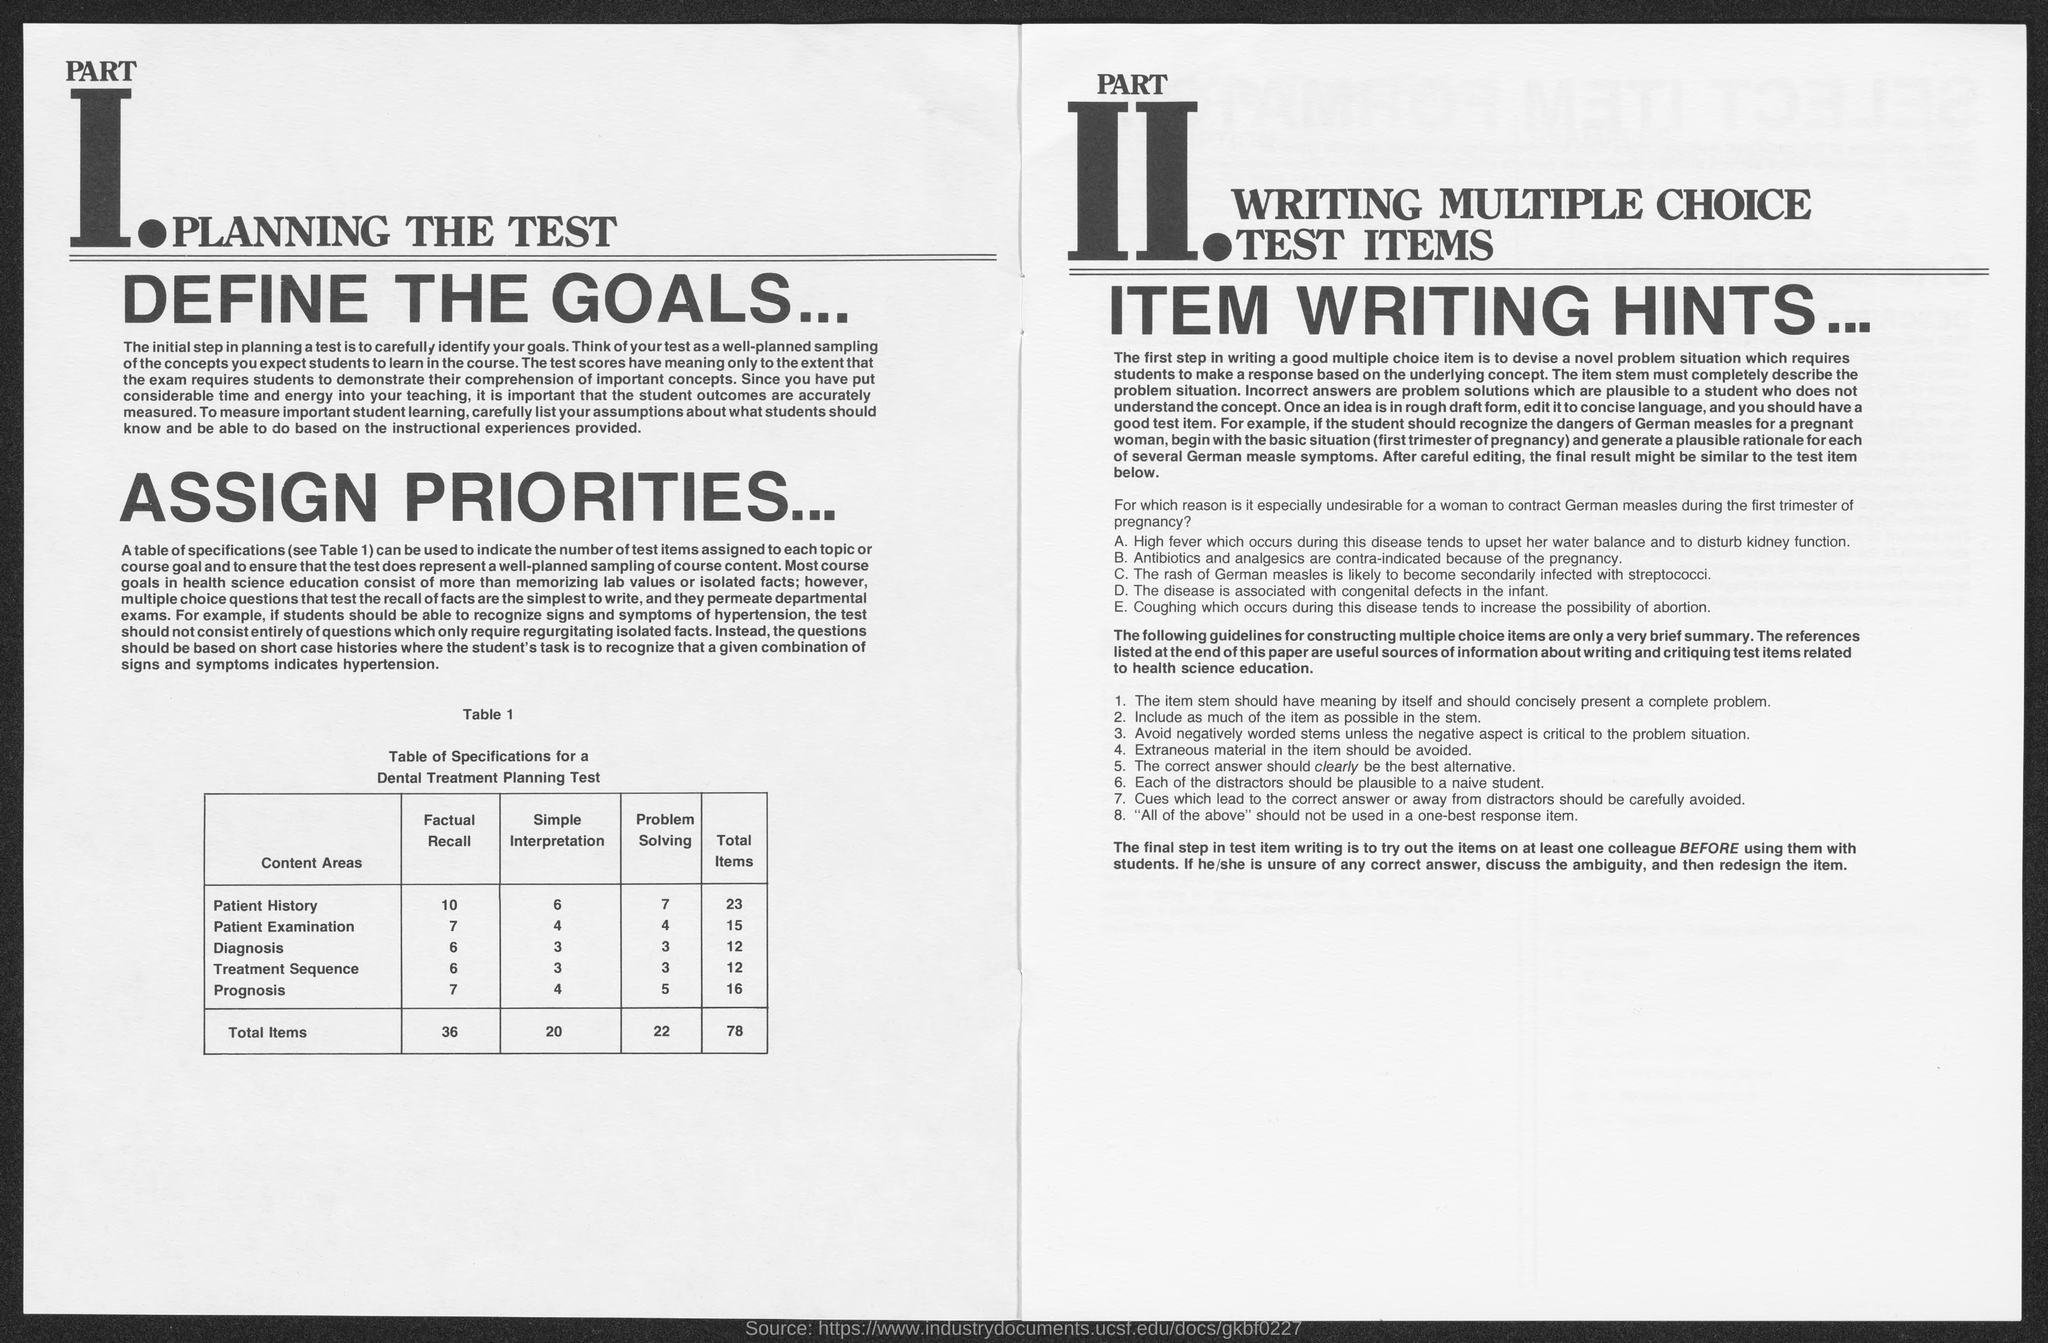Indicate a few pertinent items in this graphic. The value of the total items for prognosis mentioned in the given table is 16. The total number of items in the table is 20, based on the simple interpretation of the given values. The heading of Part 1 as mentioned in the given page is 'Planning the Test.' The value of the total items in the treatment sequence, as mentioned in the given table, is 12. The value of total items in problem solving as mentioned in the given table is 22. 